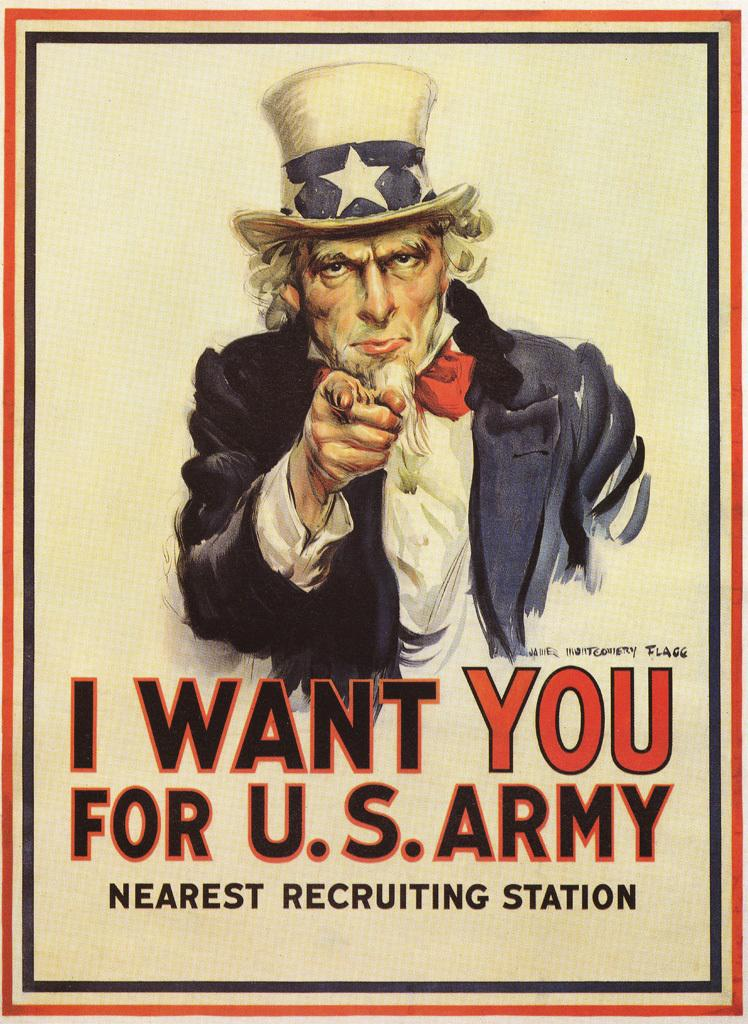Provide a one-sentence caption for the provided image. A recruitment poster for the US army with 'I want you' written on it. 